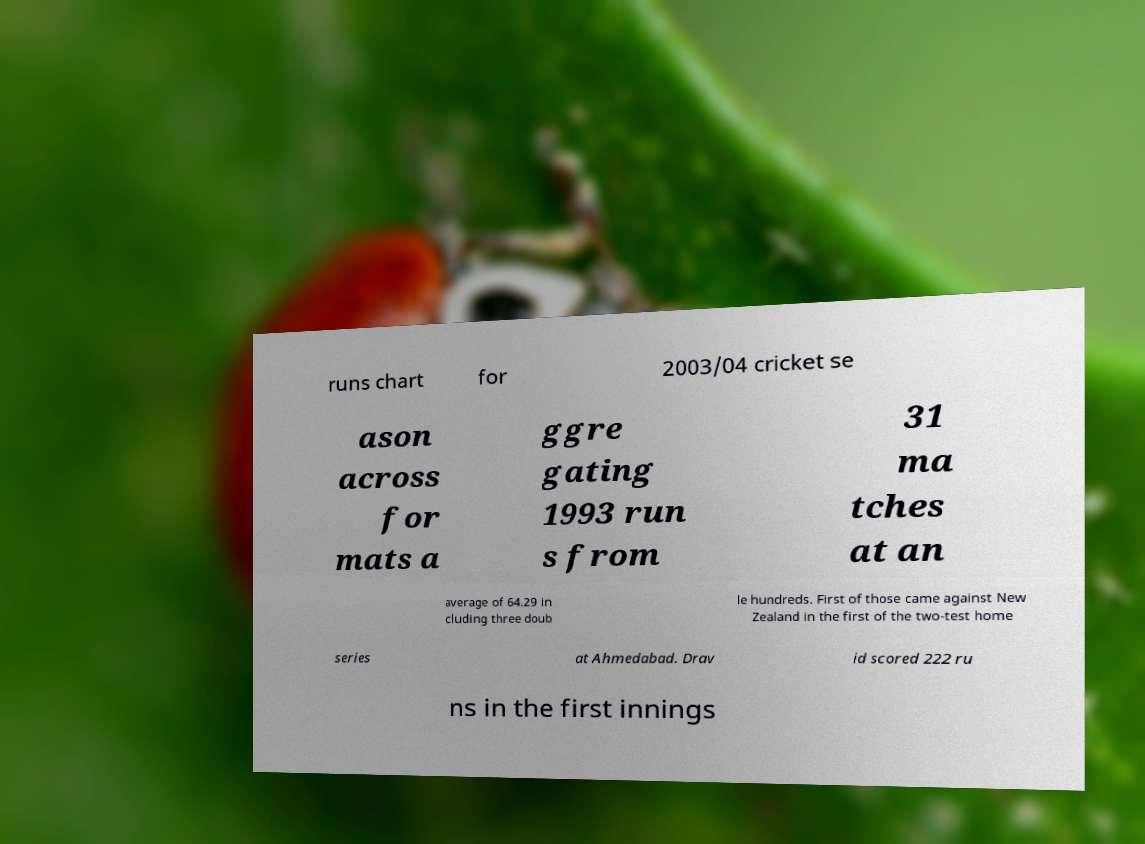Could you extract and type out the text from this image? runs chart for 2003/04 cricket se ason across for mats a ggre gating 1993 run s from 31 ma tches at an average of 64.29 in cluding three doub le hundreds. First of those came against New Zealand in the first of the two-test home series at Ahmedabad. Drav id scored 222 ru ns in the first innings 